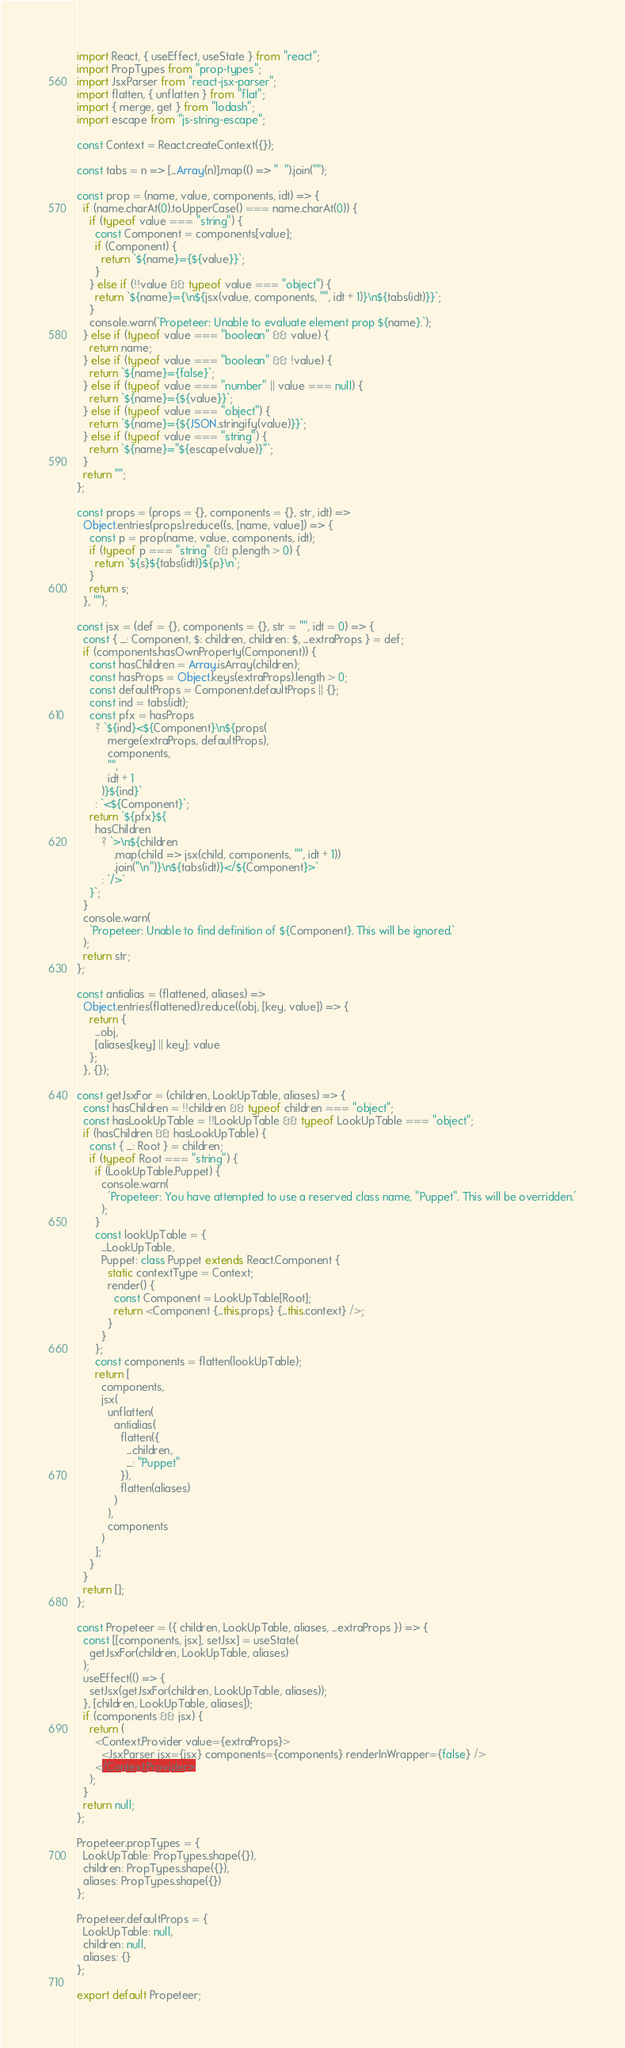<code> <loc_0><loc_0><loc_500><loc_500><_JavaScript_>import React, { useEffect, useState } from "react";
import PropTypes from "prop-types";
import JsxParser from "react-jsx-parser";
import flatten, { unflatten } from "flat";
import { merge, get } from "lodash";
import escape from "js-string-escape";

const Context = React.createContext({});

const tabs = n => [...Array(n)].map(() => "  ").join("");

const prop = (name, value, components, idt) => {
  if (name.charAt(0).toUpperCase() === name.charAt(0)) {
    if (typeof value === "string") {
      const Component = components[value];
      if (Component) {
        return `${name}={${value}}`;
      }
    } else if (!!value && typeof value === "object") {
      return `${name}={\n${jsx(value, components, "", idt + 1)}\n${tabs(idt)}}`;
    }
    console.warn(`Propeteer: Unable to evaluate element prop ${name}.`);
  } else if (typeof value === "boolean" && value) {
    return name;
  } else if (typeof value === "boolean" && !value) {
    return `${name}={false}`;
  } else if (typeof value === "number" || value === null) {
    return `${name}={${value}}`;
  } else if (typeof value === "object") {
    return `${name}={${JSON.stringify(value)}}`;
  } else if (typeof value === "string") {
    return `${name}="${escape(value)}"`;
  }
  return "";
};

const props = (props = {}, components = {}, str, idt) =>
  Object.entries(props).reduce((s, [name, value]) => {
    const p = prop(name, value, components, idt);
    if (typeof p === "string" && p.length > 0) {
      return `${s}${tabs(idt)}${p}\n`;
    }
    return s;
  }, "");

const jsx = (def = {}, components = {}, str = "", idt = 0) => {
  const { _: Component, $: children, children: $, ...extraProps } = def;
  if (components.hasOwnProperty(Component)) {
    const hasChildren = Array.isArray(children);
    const hasProps = Object.keys(extraProps).length > 0;
    const defaultProps = Component.defaultProps || {};
    const ind = tabs(idt);
    const pfx = hasProps
      ? `${ind}<${Component}\n${props(
          merge(extraProps, defaultProps),
          components,
          "",
          idt + 1
        )}${ind}`
      : `<${Component}`;
    return `${pfx}${
      hasChildren
        ? `>\n${children
            .map(child => jsx(child, components, "", idt + 1))
            .join("\n")}\n${tabs(idt)}</${Component}>`
        : `/>`
    }`;
  }
  console.warn(
    `Propeteer: Unable to find definition of ${Component}. This will be ignored.`
  );
  return str;
};

const antialias = (flattened, aliases) =>
  Object.entries(flattened).reduce((obj, [key, value]) => {
    return {
      ...obj,
      [aliases[key] || key]: value
    };
  }, {});

const getJsxFor = (children, LookUpTable, aliases) => {
  const hasChildren = !!children && typeof children === "object";
  const hasLookUpTable = !!LookUpTable && typeof LookUpTable === "object";
  if (hasChildren && hasLookUpTable) {
    const { _: Root } = children;
    if (typeof Root === "string") {
      if (LookUpTable.Puppet) {
        console.warn(
          'Propeteer: You have attempted to use a reserved class name, "Puppet". This will be overridden.'
        );
      }
      const lookUpTable = {
        ...LookUpTable,
        Puppet: class Puppet extends React.Component {
          static contextType = Context;
          render() {
            const Component = LookUpTable[Root];
            return <Component {...this.props} {...this.context} />;
          }
        }
      };
      const components = flatten(lookUpTable);
      return [
        components,
        jsx(
          unflatten(
            antialias(
              flatten({
                ...children,
                _: "Puppet"
              }),
              flatten(aliases)
            )
          ),
          components
        )
      ];
    }
  }
  return [];
};

const Propeteer = ({ children, LookUpTable, aliases, ...extraProps }) => {
  const [[components, jsx], setJsx] = useState(
    getJsxFor(children, LookUpTable, aliases)
  );
  useEffect(() => {
    setJsx(getJsxFor(children, LookUpTable, aliases));
  }, [children, LookUpTable, aliases]);
  if (components && jsx) {
    return (
      <Context.Provider value={extraProps}>
        <JsxParser jsx={jsx} components={components} renderInWrapper={false} />
      </Context.Provider>
    );
  }
  return null;
};

Propeteer.propTypes = {
  LookUpTable: PropTypes.shape({}),
  children: PropTypes.shape({}),
  aliases: PropTypes.shape({})
};

Propeteer.defaultProps = {
  LookUpTable: null,
  children: null,
  aliases: {}
};

export default Propeteer;
</code> 